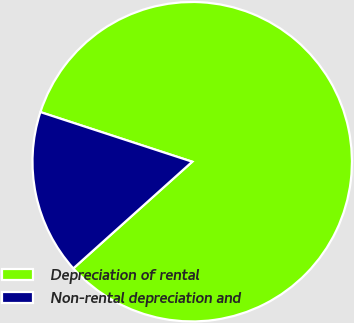Convert chart to OTSL. <chart><loc_0><loc_0><loc_500><loc_500><pie_chart><fcel>Depreciation of rental<fcel>Non-rental depreciation and<nl><fcel>83.33%<fcel>16.67%<nl></chart> 